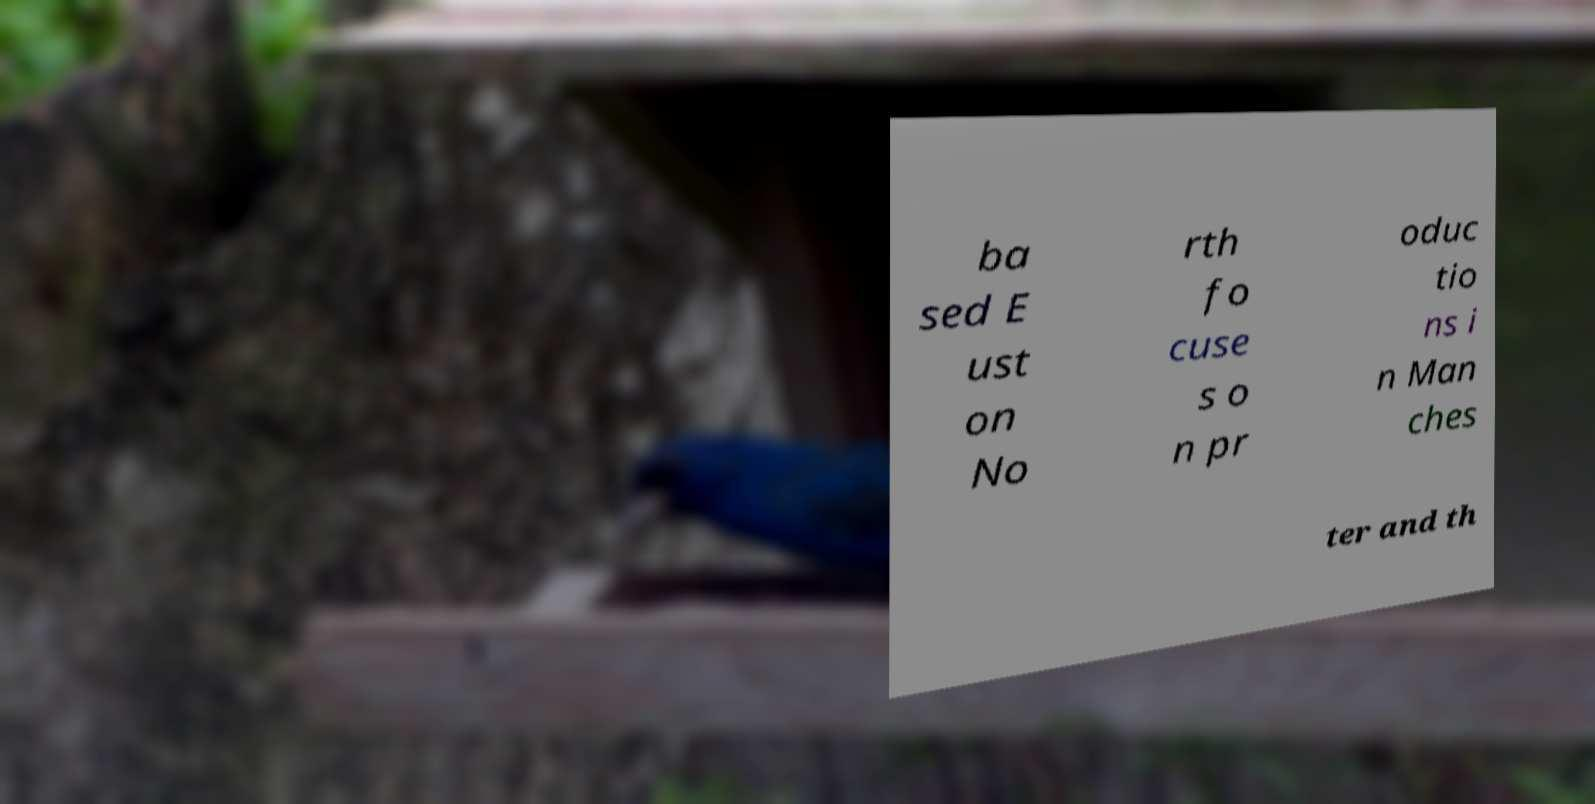I need the written content from this picture converted into text. Can you do that? ba sed E ust on No rth fo cuse s o n pr oduc tio ns i n Man ches ter and th 